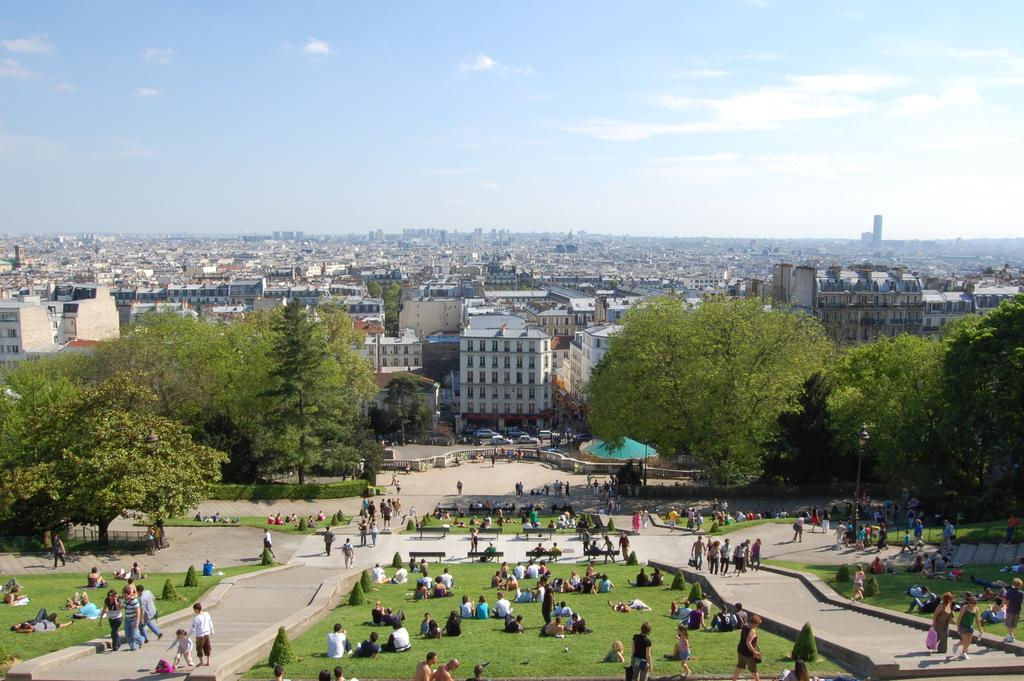What are the people in the image doing? There are people walking and sitting on the grass in the image. What can be seen in the background of the image? There are buildings and trees visible in the background of the image. What type of wool is being used to make the attempt in the image? There is no attempt or wool present in the image. Can you see any rifles in the image? There are no rifles visible in the image. 